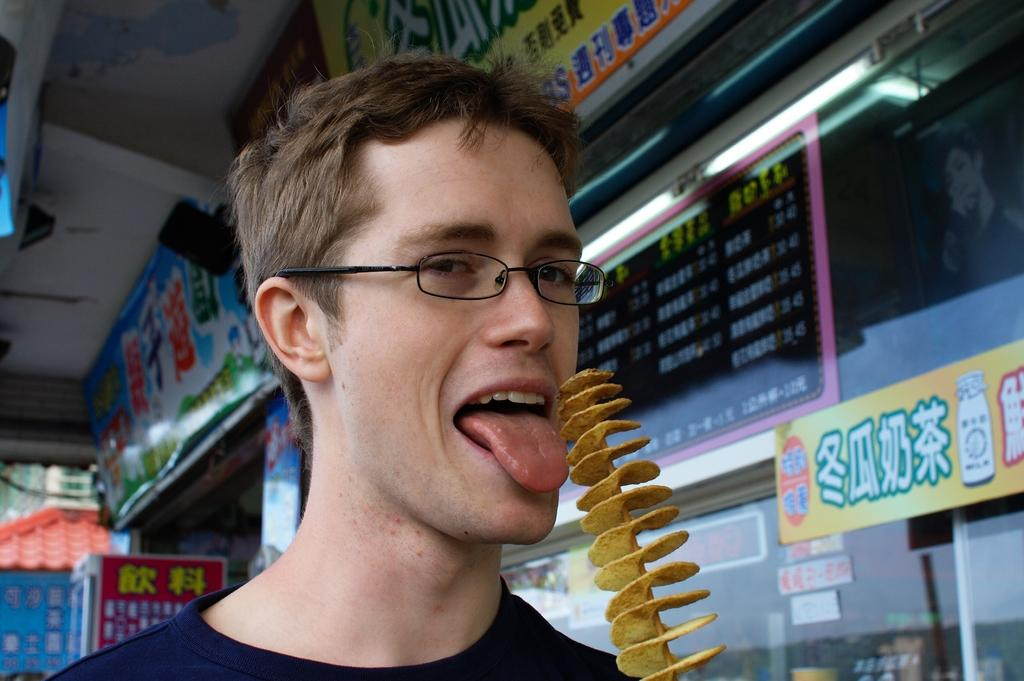Who is present in the image? There is a man in the image. What type of food can be seen in the image? There are potato skewers in the image. What can be seen in the background of the image? There are stories and information boards in the background of the image. What decision was made by the committee in the image? There is no committee present in the image, so no decision can be made. What type of coil is being used to cook the potato skewers in the image? The image does not show any coils or cooking methods; it only shows the potato skewers. 